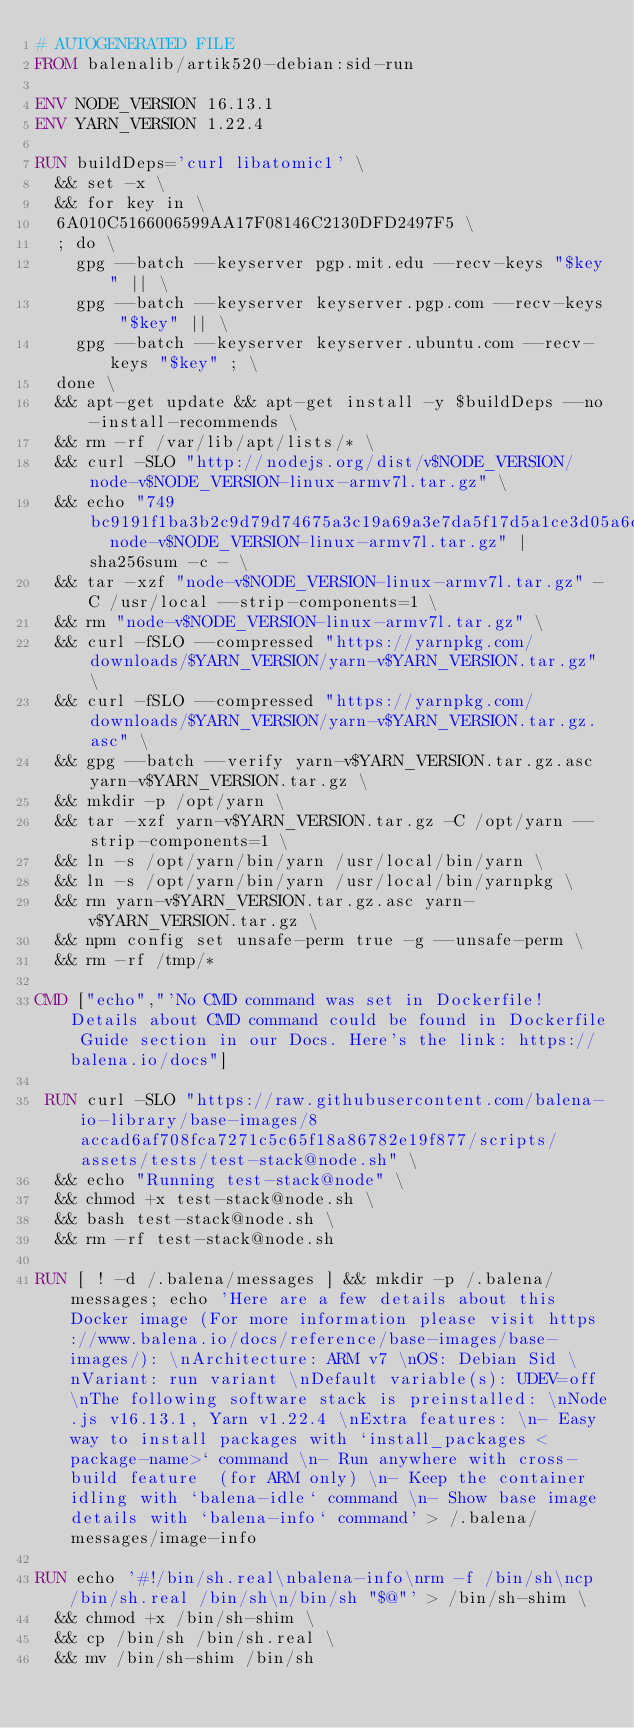Convert code to text. <code><loc_0><loc_0><loc_500><loc_500><_Dockerfile_># AUTOGENERATED FILE
FROM balenalib/artik520-debian:sid-run

ENV NODE_VERSION 16.13.1
ENV YARN_VERSION 1.22.4

RUN buildDeps='curl libatomic1' \
	&& set -x \
	&& for key in \
	6A010C5166006599AA17F08146C2130DFD2497F5 \
	; do \
		gpg --batch --keyserver pgp.mit.edu --recv-keys "$key" || \
		gpg --batch --keyserver keyserver.pgp.com --recv-keys "$key" || \
		gpg --batch --keyserver keyserver.ubuntu.com --recv-keys "$key" ; \
	done \
	&& apt-get update && apt-get install -y $buildDeps --no-install-recommends \
	&& rm -rf /var/lib/apt/lists/* \
	&& curl -SLO "http://nodejs.org/dist/v$NODE_VERSION/node-v$NODE_VERSION-linux-armv7l.tar.gz" \
	&& echo "749bc9191f1ba3b2c9d79d74675a3c19a69a3e7da5f17d5a1ce3d05a6cbef88e  node-v$NODE_VERSION-linux-armv7l.tar.gz" | sha256sum -c - \
	&& tar -xzf "node-v$NODE_VERSION-linux-armv7l.tar.gz" -C /usr/local --strip-components=1 \
	&& rm "node-v$NODE_VERSION-linux-armv7l.tar.gz" \
	&& curl -fSLO --compressed "https://yarnpkg.com/downloads/$YARN_VERSION/yarn-v$YARN_VERSION.tar.gz" \
	&& curl -fSLO --compressed "https://yarnpkg.com/downloads/$YARN_VERSION/yarn-v$YARN_VERSION.tar.gz.asc" \
	&& gpg --batch --verify yarn-v$YARN_VERSION.tar.gz.asc yarn-v$YARN_VERSION.tar.gz \
	&& mkdir -p /opt/yarn \
	&& tar -xzf yarn-v$YARN_VERSION.tar.gz -C /opt/yarn --strip-components=1 \
	&& ln -s /opt/yarn/bin/yarn /usr/local/bin/yarn \
	&& ln -s /opt/yarn/bin/yarn /usr/local/bin/yarnpkg \
	&& rm yarn-v$YARN_VERSION.tar.gz.asc yarn-v$YARN_VERSION.tar.gz \
	&& npm config set unsafe-perm true -g --unsafe-perm \
	&& rm -rf /tmp/*

CMD ["echo","'No CMD command was set in Dockerfile! Details about CMD command could be found in Dockerfile Guide section in our Docs. Here's the link: https://balena.io/docs"]

 RUN curl -SLO "https://raw.githubusercontent.com/balena-io-library/base-images/8accad6af708fca7271c5c65f18a86782e19f877/scripts/assets/tests/test-stack@node.sh" \
  && echo "Running test-stack@node" \
  && chmod +x test-stack@node.sh \
  && bash test-stack@node.sh \
  && rm -rf test-stack@node.sh 

RUN [ ! -d /.balena/messages ] && mkdir -p /.balena/messages; echo 'Here are a few details about this Docker image (For more information please visit https://www.balena.io/docs/reference/base-images/base-images/): \nArchitecture: ARM v7 \nOS: Debian Sid \nVariant: run variant \nDefault variable(s): UDEV=off \nThe following software stack is preinstalled: \nNode.js v16.13.1, Yarn v1.22.4 \nExtra features: \n- Easy way to install packages with `install_packages <package-name>` command \n- Run anywhere with cross-build feature  (for ARM only) \n- Keep the container idling with `balena-idle` command \n- Show base image details with `balena-info` command' > /.balena/messages/image-info

RUN echo '#!/bin/sh.real\nbalena-info\nrm -f /bin/sh\ncp /bin/sh.real /bin/sh\n/bin/sh "$@"' > /bin/sh-shim \
	&& chmod +x /bin/sh-shim \
	&& cp /bin/sh /bin/sh.real \
	&& mv /bin/sh-shim /bin/sh</code> 